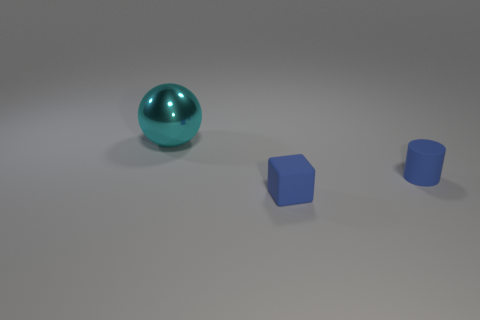The blue object that is the same size as the blue cube is what shape?
Your answer should be very brief. Cylinder. What number of other things are there of the same material as the large cyan object
Your answer should be compact. 0. Are there an equal number of matte cylinders left of the big shiny ball and big cyan objects?
Ensure brevity in your answer.  No. There is a cylinder; is it the same size as the cyan ball that is behind the block?
Your answer should be very brief. No. The blue thing on the right side of the blue cube has what shape?
Make the answer very short. Cylinder. Is there any other thing that is the same shape as the cyan thing?
Offer a very short reply. No. Is there a brown metal thing?
Your response must be concise. No. There is a blue object on the left side of the tiny blue matte cylinder; is its size the same as the object left of the cube?
Offer a very short reply. No. There is a thing that is both in front of the cyan metallic sphere and to the left of the small blue rubber cylinder; what material is it made of?
Your response must be concise. Rubber. There is a shiny object; how many tiny things are right of it?
Your answer should be very brief. 2. 